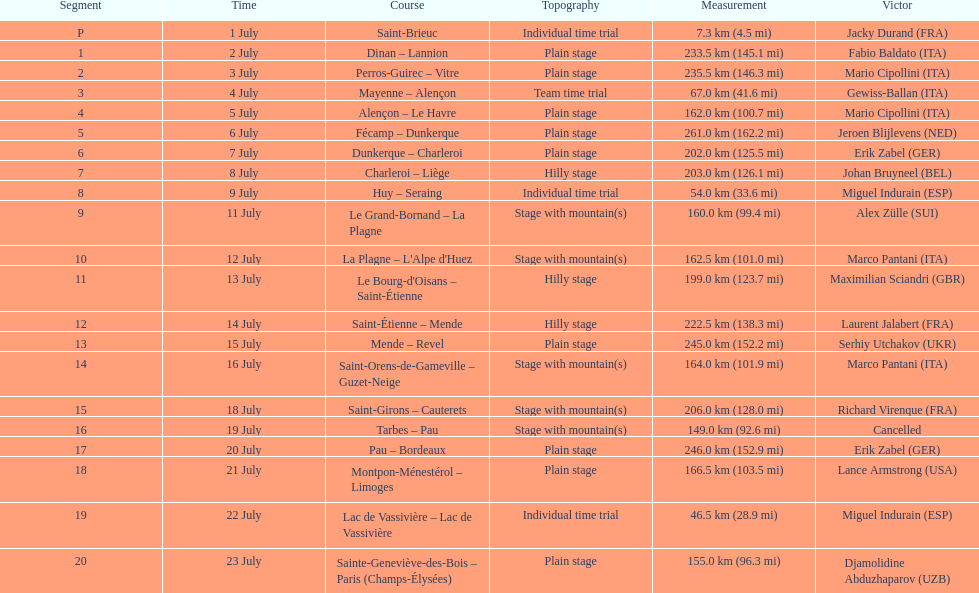Which country had more stage-winners than any other country? Italy. 